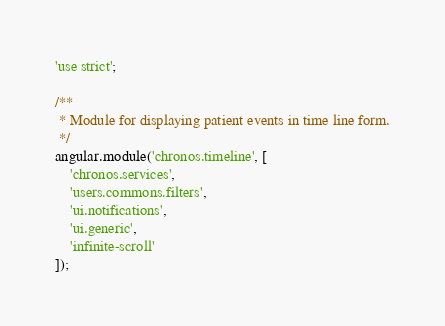Convert code to text. <code><loc_0><loc_0><loc_500><loc_500><_JavaScript_>'use strict';

/**
 * Module for displaying patient events in time line form.
 */
angular.module('chronos.timeline', [
    'chronos.services',
    'users.commons.filters',
    'ui.notifications',
    'ui.generic',
    'infinite-scroll'
]);
</code> 